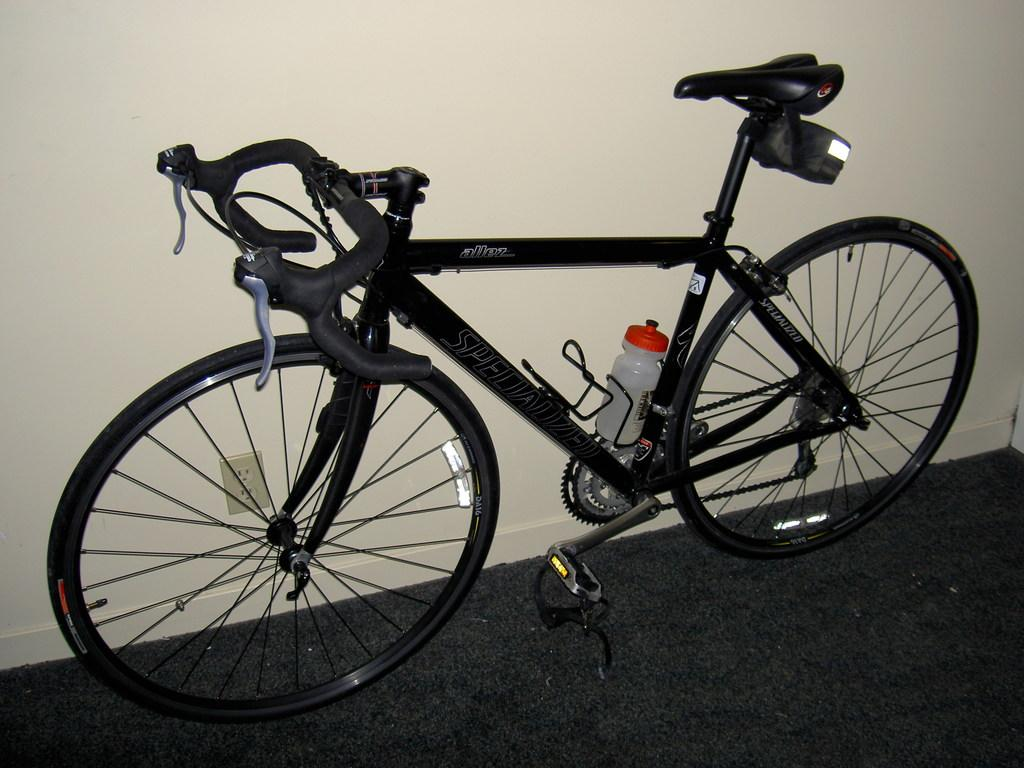What color is the bicycle in the image? The bicycle in the image is black. What can be seen attached to the bicycle? There is a water bottle attached to the bicycle. What is visible in the background of the image? There is a wall in the background of the image. What is visible at the bottom of the image? The floor is visible at the bottom of the image. What type of horn can be heard in the image? There is no horn present in the image, so it is not possible to hear any horn. 